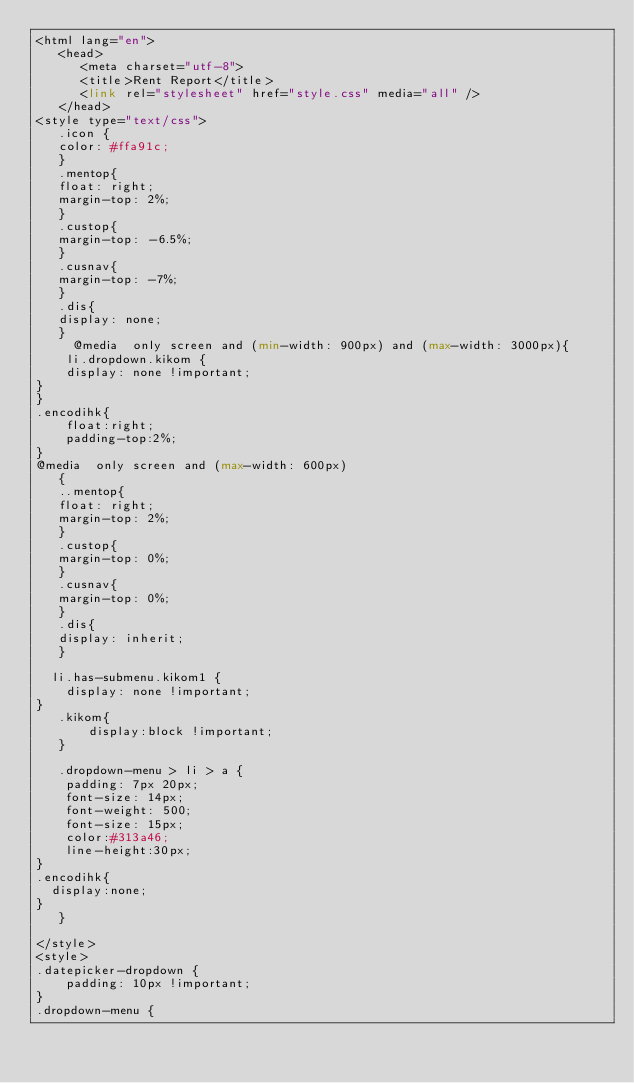Convert code to text. <code><loc_0><loc_0><loc_500><loc_500><_PHP_><html lang="en">
   <head>
      <meta charset="utf-8">
      <title>Rent Report</title>
      <link rel="stylesheet" href="style.css" media="all" />
   </head>
<style type="text/css">
   .icon {
   color: #ffa91c;
   }
   .mentop{
   float: right;
   margin-top: 2%;
   }
   .custop{
   margin-top: -6.5%;
   }
   .cusnav{
   margin-top: -7%;
   }
   .dis{
   display: none;
   }
     @media  only screen and (min-width: 900px) and (max-width: 3000px){
    li.dropdown.kikom {
    display: none !important;
}
}
.encodihk{
    float:right;
    padding-top:2%;
}
@media  only screen and (max-width: 600px)
   {
   ..mentop{
   float: right;
   margin-top: 2%;
   }
   .custop{
   margin-top: 0%;
   }
   .cusnav{
   margin-top: 0%;
   }
   .dis{
   display: inherit;
   }

  li.has-submenu.kikom1 {
    display: none !important;
}
   .kikom{
       display:block !important;
   }
   
   .dropdown-menu > li > a {
    padding: 7px 20px;
    font-size: 14px;
    font-weight: 500;
    font-size: 15px;
    color:#313a46;
    line-height:30px;
}
.encodihk{
  display:none;
}
   }
 
</style>
<style>
.datepicker-dropdown {
    padding: 10px !important;
}
.dropdown-menu {</code> 